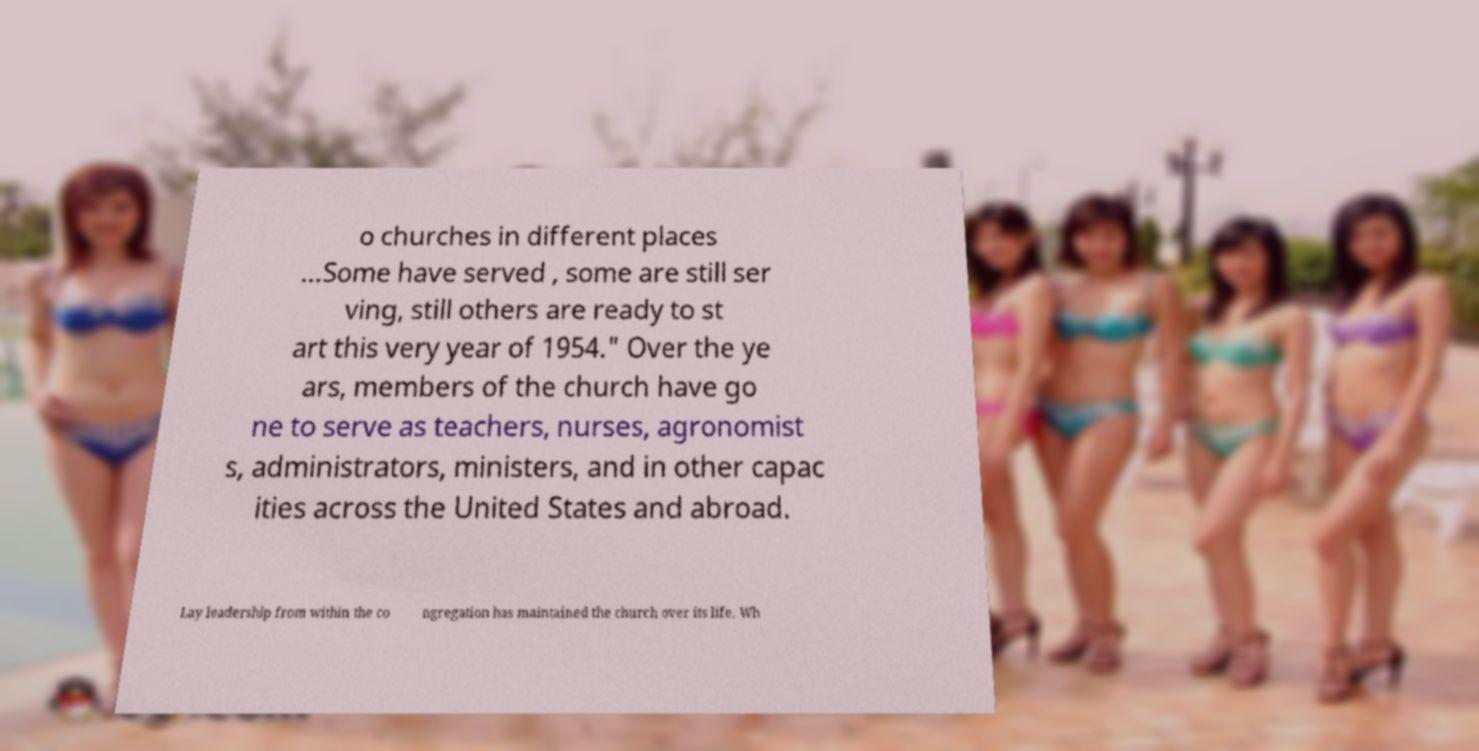Could you assist in decoding the text presented in this image and type it out clearly? o churches in different places ...Some have served , some are still ser ving, still others are ready to st art this very year of 1954." Over the ye ars, members of the church have go ne to serve as teachers, nurses, agronomist s, administrators, ministers, and in other capac ities across the United States and abroad. Lay leadership from within the co ngregation has maintained the church over its life. Wh 